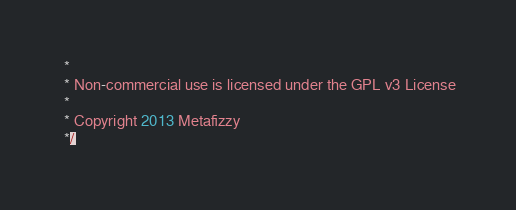<code> <loc_0><loc_0><loc_500><loc_500><_JavaScript_> *
 * Non-commercial use is licensed under the GPL v3 License
 *
 * Copyright 2013 Metafizzy
 */
</code> 